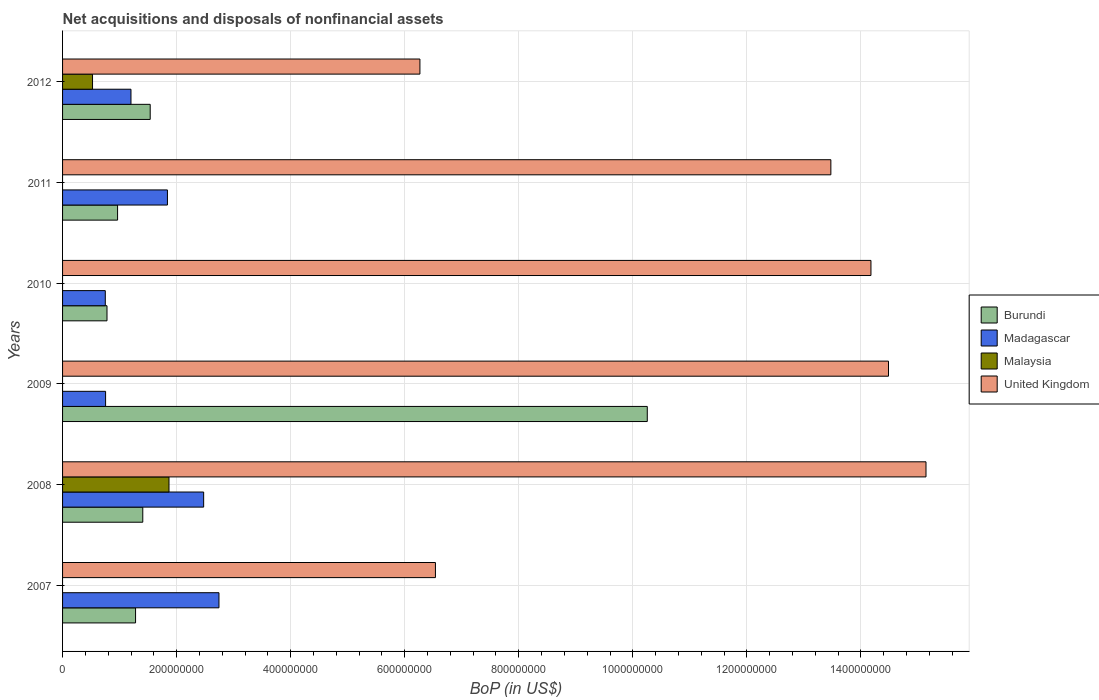How many different coloured bars are there?
Your answer should be very brief. 4. Are the number of bars on each tick of the Y-axis equal?
Give a very brief answer. No. How many bars are there on the 2nd tick from the top?
Offer a very short reply. 3. What is the Balance of Payments in Burundi in 2008?
Your answer should be very brief. 1.41e+08. Across all years, what is the maximum Balance of Payments in United Kingdom?
Offer a very short reply. 1.51e+09. Across all years, what is the minimum Balance of Payments in Burundi?
Make the answer very short. 7.79e+07. What is the total Balance of Payments in Burundi in the graph?
Your answer should be compact. 1.62e+09. What is the difference between the Balance of Payments in United Kingdom in 2007 and that in 2010?
Your response must be concise. -7.64e+08. What is the difference between the Balance of Payments in United Kingdom in 2009 and the Balance of Payments in Madagascar in 2008?
Provide a short and direct response. 1.20e+09. What is the average Balance of Payments in Madagascar per year?
Give a very brief answer. 1.63e+08. In the year 2008, what is the difference between the Balance of Payments in Malaysia and Balance of Payments in United Kingdom?
Keep it short and to the point. -1.33e+09. In how many years, is the Balance of Payments in Malaysia greater than 80000000 US$?
Give a very brief answer. 1. What is the ratio of the Balance of Payments in United Kingdom in 2010 to that in 2011?
Provide a short and direct response. 1.05. What is the difference between the highest and the second highest Balance of Payments in Madagascar?
Provide a short and direct response. 2.68e+07. What is the difference between the highest and the lowest Balance of Payments in Burundi?
Give a very brief answer. 9.47e+08. Is the sum of the Balance of Payments in United Kingdom in 2008 and 2011 greater than the maximum Balance of Payments in Madagascar across all years?
Offer a terse response. Yes. How many bars are there?
Give a very brief answer. 20. How many years are there in the graph?
Give a very brief answer. 6. What is the difference between two consecutive major ticks on the X-axis?
Provide a short and direct response. 2.00e+08. Are the values on the major ticks of X-axis written in scientific E-notation?
Provide a succinct answer. No. Does the graph contain any zero values?
Ensure brevity in your answer.  Yes. Where does the legend appear in the graph?
Your answer should be compact. Center right. How are the legend labels stacked?
Your response must be concise. Vertical. What is the title of the graph?
Your answer should be very brief. Net acquisitions and disposals of nonfinancial assets. Does "Cayman Islands" appear as one of the legend labels in the graph?
Make the answer very short. No. What is the label or title of the X-axis?
Your response must be concise. BoP (in US$). What is the BoP (in US$) in Burundi in 2007?
Your answer should be very brief. 1.28e+08. What is the BoP (in US$) of Madagascar in 2007?
Your response must be concise. 2.74e+08. What is the BoP (in US$) of Malaysia in 2007?
Ensure brevity in your answer.  0. What is the BoP (in US$) of United Kingdom in 2007?
Your answer should be very brief. 6.54e+08. What is the BoP (in US$) in Burundi in 2008?
Ensure brevity in your answer.  1.41e+08. What is the BoP (in US$) of Madagascar in 2008?
Give a very brief answer. 2.47e+08. What is the BoP (in US$) in Malaysia in 2008?
Your response must be concise. 1.87e+08. What is the BoP (in US$) of United Kingdom in 2008?
Your answer should be very brief. 1.51e+09. What is the BoP (in US$) of Burundi in 2009?
Provide a succinct answer. 1.03e+09. What is the BoP (in US$) in Madagascar in 2009?
Keep it short and to the point. 7.55e+07. What is the BoP (in US$) in Malaysia in 2009?
Provide a succinct answer. 0. What is the BoP (in US$) in United Kingdom in 2009?
Give a very brief answer. 1.45e+09. What is the BoP (in US$) of Burundi in 2010?
Ensure brevity in your answer.  7.79e+07. What is the BoP (in US$) of Madagascar in 2010?
Your answer should be compact. 7.49e+07. What is the BoP (in US$) of Malaysia in 2010?
Offer a terse response. 0. What is the BoP (in US$) in United Kingdom in 2010?
Provide a succinct answer. 1.42e+09. What is the BoP (in US$) of Burundi in 2011?
Your response must be concise. 9.65e+07. What is the BoP (in US$) of Madagascar in 2011?
Your response must be concise. 1.84e+08. What is the BoP (in US$) in Malaysia in 2011?
Ensure brevity in your answer.  0. What is the BoP (in US$) in United Kingdom in 2011?
Your response must be concise. 1.35e+09. What is the BoP (in US$) in Burundi in 2012?
Give a very brief answer. 1.54e+08. What is the BoP (in US$) of Madagascar in 2012?
Ensure brevity in your answer.  1.20e+08. What is the BoP (in US$) in Malaysia in 2012?
Give a very brief answer. 5.25e+07. What is the BoP (in US$) of United Kingdom in 2012?
Your response must be concise. 6.27e+08. Across all years, what is the maximum BoP (in US$) of Burundi?
Provide a succinct answer. 1.03e+09. Across all years, what is the maximum BoP (in US$) in Madagascar?
Offer a terse response. 2.74e+08. Across all years, what is the maximum BoP (in US$) of Malaysia?
Your answer should be compact. 1.87e+08. Across all years, what is the maximum BoP (in US$) in United Kingdom?
Your answer should be very brief. 1.51e+09. Across all years, what is the minimum BoP (in US$) in Burundi?
Your answer should be compact. 7.79e+07. Across all years, what is the minimum BoP (in US$) of Madagascar?
Offer a terse response. 7.49e+07. Across all years, what is the minimum BoP (in US$) in United Kingdom?
Make the answer very short. 6.27e+08. What is the total BoP (in US$) of Burundi in the graph?
Keep it short and to the point. 1.62e+09. What is the total BoP (in US$) in Madagascar in the graph?
Your answer should be compact. 9.76e+08. What is the total BoP (in US$) of Malaysia in the graph?
Offer a terse response. 2.39e+08. What is the total BoP (in US$) of United Kingdom in the graph?
Give a very brief answer. 7.01e+09. What is the difference between the BoP (in US$) of Burundi in 2007 and that in 2008?
Give a very brief answer. -1.27e+07. What is the difference between the BoP (in US$) in Madagascar in 2007 and that in 2008?
Your response must be concise. 2.68e+07. What is the difference between the BoP (in US$) of United Kingdom in 2007 and that in 2008?
Your response must be concise. -8.60e+08. What is the difference between the BoP (in US$) of Burundi in 2007 and that in 2009?
Provide a short and direct response. -8.97e+08. What is the difference between the BoP (in US$) of Madagascar in 2007 and that in 2009?
Ensure brevity in your answer.  1.99e+08. What is the difference between the BoP (in US$) of United Kingdom in 2007 and that in 2009?
Your answer should be compact. -7.94e+08. What is the difference between the BoP (in US$) of Burundi in 2007 and that in 2010?
Ensure brevity in your answer.  5.01e+07. What is the difference between the BoP (in US$) of Madagascar in 2007 and that in 2010?
Provide a short and direct response. 1.99e+08. What is the difference between the BoP (in US$) of United Kingdom in 2007 and that in 2010?
Provide a short and direct response. -7.64e+08. What is the difference between the BoP (in US$) in Burundi in 2007 and that in 2011?
Make the answer very short. 3.15e+07. What is the difference between the BoP (in US$) of Madagascar in 2007 and that in 2011?
Your response must be concise. 9.04e+07. What is the difference between the BoP (in US$) of United Kingdom in 2007 and that in 2011?
Give a very brief answer. -6.93e+08. What is the difference between the BoP (in US$) in Burundi in 2007 and that in 2012?
Ensure brevity in your answer.  -2.57e+07. What is the difference between the BoP (in US$) in Madagascar in 2007 and that in 2012?
Your answer should be compact. 1.54e+08. What is the difference between the BoP (in US$) of United Kingdom in 2007 and that in 2012?
Your response must be concise. 2.72e+07. What is the difference between the BoP (in US$) of Burundi in 2008 and that in 2009?
Your answer should be very brief. -8.85e+08. What is the difference between the BoP (in US$) in Madagascar in 2008 and that in 2009?
Make the answer very short. 1.72e+08. What is the difference between the BoP (in US$) of United Kingdom in 2008 and that in 2009?
Your answer should be compact. 6.58e+07. What is the difference between the BoP (in US$) of Burundi in 2008 and that in 2010?
Your response must be concise. 6.28e+07. What is the difference between the BoP (in US$) in Madagascar in 2008 and that in 2010?
Offer a very short reply. 1.72e+08. What is the difference between the BoP (in US$) in United Kingdom in 2008 and that in 2010?
Give a very brief answer. 9.65e+07. What is the difference between the BoP (in US$) of Burundi in 2008 and that in 2011?
Offer a very short reply. 4.42e+07. What is the difference between the BoP (in US$) of Madagascar in 2008 and that in 2011?
Provide a succinct answer. 6.35e+07. What is the difference between the BoP (in US$) of United Kingdom in 2008 and that in 2011?
Provide a succinct answer. 1.67e+08. What is the difference between the BoP (in US$) in Burundi in 2008 and that in 2012?
Give a very brief answer. -1.30e+07. What is the difference between the BoP (in US$) of Madagascar in 2008 and that in 2012?
Provide a short and direct response. 1.27e+08. What is the difference between the BoP (in US$) in Malaysia in 2008 and that in 2012?
Offer a very short reply. 1.34e+08. What is the difference between the BoP (in US$) in United Kingdom in 2008 and that in 2012?
Your answer should be very brief. 8.87e+08. What is the difference between the BoP (in US$) of Burundi in 2009 and that in 2010?
Your answer should be compact. 9.47e+08. What is the difference between the BoP (in US$) of Madagascar in 2009 and that in 2010?
Offer a terse response. 5.31e+05. What is the difference between the BoP (in US$) of United Kingdom in 2009 and that in 2010?
Your answer should be very brief. 3.08e+07. What is the difference between the BoP (in US$) in Burundi in 2009 and that in 2011?
Make the answer very short. 9.29e+08. What is the difference between the BoP (in US$) of Madagascar in 2009 and that in 2011?
Offer a terse response. -1.08e+08. What is the difference between the BoP (in US$) of United Kingdom in 2009 and that in 2011?
Your response must be concise. 1.01e+08. What is the difference between the BoP (in US$) in Burundi in 2009 and that in 2012?
Give a very brief answer. 8.72e+08. What is the difference between the BoP (in US$) in Madagascar in 2009 and that in 2012?
Provide a succinct answer. -4.45e+07. What is the difference between the BoP (in US$) of United Kingdom in 2009 and that in 2012?
Keep it short and to the point. 8.22e+08. What is the difference between the BoP (in US$) of Burundi in 2010 and that in 2011?
Your answer should be very brief. -1.86e+07. What is the difference between the BoP (in US$) in Madagascar in 2010 and that in 2011?
Offer a terse response. -1.09e+08. What is the difference between the BoP (in US$) of United Kingdom in 2010 and that in 2011?
Your response must be concise. 7.03e+07. What is the difference between the BoP (in US$) in Burundi in 2010 and that in 2012?
Give a very brief answer. -7.58e+07. What is the difference between the BoP (in US$) of Madagascar in 2010 and that in 2012?
Provide a short and direct response. -4.50e+07. What is the difference between the BoP (in US$) in United Kingdom in 2010 and that in 2012?
Your response must be concise. 7.91e+08. What is the difference between the BoP (in US$) of Burundi in 2011 and that in 2012?
Provide a short and direct response. -5.72e+07. What is the difference between the BoP (in US$) of Madagascar in 2011 and that in 2012?
Offer a very short reply. 6.40e+07. What is the difference between the BoP (in US$) in United Kingdom in 2011 and that in 2012?
Offer a very short reply. 7.21e+08. What is the difference between the BoP (in US$) in Burundi in 2007 and the BoP (in US$) in Madagascar in 2008?
Give a very brief answer. -1.19e+08. What is the difference between the BoP (in US$) of Burundi in 2007 and the BoP (in US$) of Malaysia in 2008?
Provide a short and direct response. -5.86e+07. What is the difference between the BoP (in US$) of Burundi in 2007 and the BoP (in US$) of United Kingdom in 2008?
Your answer should be compact. -1.39e+09. What is the difference between the BoP (in US$) in Madagascar in 2007 and the BoP (in US$) in Malaysia in 2008?
Your response must be concise. 8.76e+07. What is the difference between the BoP (in US$) in Madagascar in 2007 and the BoP (in US$) in United Kingdom in 2008?
Offer a terse response. -1.24e+09. What is the difference between the BoP (in US$) of Burundi in 2007 and the BoP (in US$) of Madagascar in 2009?
Make the answer very short. 5.26e+07. What is the difference between the BoP (in US$) of Burundi in 2007 and the BoP (in US$) of United Kingdom in 2009?
Your response must be concise. -1.32e+09. What is the difference between the BoP (in US$) in Madagascar in 2007 and the BoP (in US$) in United Kingdom in 2009?
Offer a terse response. -1.17e+09. What is the difference between the BoP (in US$) in Burundi in 2007 and the BoP (in US$) in Madagascar in 2010?
Provide a succinct answer. 5.31e+07. What is the difference between the BoP (in US$) of Burundi in 2007 and the BoP (in US$) of United Kingdom in 2010?
Provide a short and direct response. -1.29e+09. What is the difference between the BoP (in US$) of Madagascar in 2007 and the BoP (in US$) of United Kingdom in 2010?
Keep it short and to the point. -1.14e+09. What is the difference between the BoP (in US$) in Burundi in 2007 and the BoP (in US$) in Madagascar in 2011?
Ensure brevity in your answer.  -5.59e+07. What is the difference between the BoP (in US$) in Burundi in 2007 and the BoP (in US$) in United Kingdom in 2011?
Your response must be concise. -1.22e+09. What is the difference between the BoP (in US$) of Madagascar in 2007 and the BoP (in US$) of United Kingdom in 2011?
Keep it short and to the point. -1.07e+09. What is the difference between the BoP (in US$) in Burundi in 2007 and the BoP (in US$) in Madagascar in 2012?
Keep it short and to the point. 8.08e+06. What is the difference between the BoP (in US$) of Burundi in 2007 and the BoP (in US$) of Malaysia in 2012?
Your answer should be very brief. 7.55e+07. What is the difference between the BoP (in US$) of Burundi in 2007 and the BoP (in US$) of United Kingdom in 2012?
Your response must be concise. -4.99e+08. What is the difference between the BoP (in US$) of Madagascar in 2007 and the BoP (in US$) of Malaysia in 2012?
Your answer should be very brief. 2.22e+08. What is the difference between the BoP (in US$) in Madagascar in 2007 and the BoP (in US$) in United Kingdom in 2012?
Make the answer very short. -3.52e+08. What is the difference between the BoP (in US$) in Burundi in 2008 and the BoP (in US$) in Madagascar in 2009?
Offer a terse response. 6.52e+07. What is the difference between the BoP (in US$) of Burundi in 2008 and the BoP (in US$) of United Kingdom in 2009?
Keep it short and to the point. -1.31e+09. What is the difference between the BoP (in US$) in Madagascar in 2008 and the BoP (in US$) in United Kingdom in 2009?
Your response must be concise. -1.20e+09. What is the difference between the BoP (in US$) of Malaysia in 2008 and the BoP (in US$) of United Kingdom in 2009?
Provide a succinct answer. -1.26e+09. What is the difference between the BoP (in US$) of Burundi in 2008 and the BoP (in US$) of Madagascar in 2010?
Keep it short and to the point. 6.57e+07. What is the difference between the BoP (in US$) of Burundi in 2008 and the BoP (in US$) of United Kingdom in 2010?
Offer a very short reply. -1.28e+09. What is the difference between the BoP (in US$) of Madagascar in 2008 and the BoP (in US$) of United Kingdom in 2010?
Provide a succinct answer. -1.17e+09. What is the difference between the BoP (in US$) of Malaysia in 2008 and the BoP (in US$) of United Kingdom in 2010?
Give a very brief answer. -1.23e+09. What is the difference between the BoP (in US$) in Burundi in 2008 and the BoP (in US$) in Madagascar in 2011?
Provide a succinct answer. -4.32e+07. What is the difference between the BoP (in US$) in Burundi in 2008 and the BoP (in US$) in United Kingdom in 2011?
Offer a terse response. -1.21e+09. What is the difference between the BoP (in US$) in Madagascar in 2008 and the BoP (in US$) in United Kingdom in 2011?
Make the answer very short. -1.10e+09. What is the difference between the BoP (in US$) of Malaysia in 2008 and the BoP (in US$) of United Kingdom in 2011?
Keep it short and to the point. -1.16e+09. What is the difference between the BoP (in US$) in Burundi in 2008 and the BoP (in US$) in Madagascar in 2012?
Your response must be concise. 2.07e+07. What is the difference between the BoP (in US$) in Burundi in 2008 and the BoP (in US$) in Malaysia in 2012?
Offer a very short reply. 8.81e+07. What is the difference between the BoP (in US$) in Burundi in 2008 and the BoP (in US$) in United Kingdom in 2012?
Offer a very short reply. -4.86e+08. What is the difference between the BoP (in US$) in Madagascar in 2008 and the BoP (in US$) in Malaysia in 2012?
Your answer should be very brief. 1.95e+08. What is the difference between the BoP (in US$) in Madagascar in 2008 and the BoP (in US$) in United Kingdom in 2012?
Offer a terse response. -3.79e+08. What is the difference between the BoP (in US$) in Malaysia in 2008 and the BoP (in US$) in United Kingdom in 2012?
Your response must be concise. -4.40e+08. What is the difference between the BoP (in US$) of Burundi in 2009 and the BoP (in US$) of Madagascar in 2010?
Keep it short and to the point. 9.50e+08. What is the difference between the BoP (in US$) in Burundi in 2009 and the BoP (in US$) in United Kingdom in 2010?
Your answer should be very brief. -3.92e+08. What is the difference between the BoP (in US$) of Madagascar in 2009 and the BoP (in US$) of United Kingdom in 2010?
Offer a very short reply. -1.34e+09. What is the difference between the BoP (in US$) in Burundi in 2009 and the BoP (in US$) in Madagascar in 2011?
Offer a very short reply. 8.41e+08. What is the difference between the BoP (in US$) of Burundi in 2009 and the BoP (in US$) of United Kingdom in 2011?
Offer a terse response. -3.22e+08. What is the difference between the BoP (in US$) of Madagascar in 2009 and the BoP (in US$) of United Kingdom in 2011?
Make the answer very short. -1.27e+09. What is the difference between the BoP (in US$) of Burundi in 2009 and the BoP (in US$) of Madagascar in 2012?
Keep it short and to the point. 9.05e+08. What is the difference between the BoP (in US$) in Burundi in 2009 and the BoP (in US$) in Malaysia in 2012?
Ensure brevity in your answer.  9.73e+08. What is the difference between the BoP (in US$) of Burundi in 2009 and the BoP (in US$) of United Kingdom in 2012?
Your answer should be compact. 3.99e+08. What is the difference between the BoP (in US$) in Madagascar in 2009 and the BoP (in US$) in Malaysia in 2012?
Offer a terse response. 2.29e+07. What is the difference between the BoP (in US$) of Madagascar in 2009 and the BoP (in US$) of United Kingdom in 2012?
Provide a short and direct response. -5.51e+08. What is the difference between the BoP (in US$) in Burundi in 2010 and the BoP (in US$) in Madagascar in 2011?
Your answer should be compact. -1.06e+08. What is the difference between the BoP (in US$) in Burundi in 2010 and the BoP (in US$) in United Kingdom in 2011?
Your answer should be very brief. -1.27e+09. What is the difference between the BoP (in US$) of Madagascar in 2010 and the BoP (in US$) of United Kingdom in 2011?
Give a very brief answer. -1.27e+09. What is the difference between the BoP (in US$) in Burundi in 2010 and the BoP (in US$) in Madagascar in 2012?
Your answer should be very brief. -4.20e+07. What is the difference between the BoP (in US$) of Burundi in 2010 and the BoP (in US$) of Malaysia in 2012?
Provide a short and direct response. 2.54e+07. What is the difference between the BoP (in US$) of Burundi in 2010 and the BoP (in US$) of United Kingdom in 2012?
Offer a very short reply. -5.49e+08. What is the difference between the BoP (in US$) of Madagascar in 2010 and the BoP (in US$) of Malaysia in 2012?
Your answer should be compact. 2.24e+07. What is the difference between the BoP (in US$) of Madagascar in 2010 and the BoP (in US$) of United Kingdom in 2012?
Offer a very short reply. -5.52e+08. What is the difference between the BoP (in US$) of Burundi in 2011 and the BoP (in US$) of Madagascar in 2012?
Your answer should be very brief. -2.35e+07. What is the difference between the BoP (in US$) of Burundi in 2011 and the BoP (in US$) of Malaysia in 2012?
Your answer should be very brief. 4.39e+07. What is the difference between the BoP (in US$) in Burundi in 2011 and the BoP (in US$) in United Kingdom in 2012?
Provide a short and direct response. -5.30e+08. What is the difference between the BoP (in US$) in Madagascar in 2011 and the BoP (in US$) in Malaysia in 2012?
Make the answer very short. 1.31e+08. What is the difference between the BoP (in US$) of Madagascar in 2011 and the BoP (in US$) of United Kingdom in 2012?
Offer a terse response. -4.43e+08. What is the average BoP (in US$) in Burundi per year?
Ensure brevity in your answer.  2.70e+08. What is the average BoP (in US$) in Madagascar per year?
Give a very brief answer. 1.63e+08. What is the average BoP (in US$) in Malaysia per year?
Keep it short and to the point. 3.99e+07. What is the average BoP (in US$) in United Kingdom per year?
Your response must be concise. 1.17e+09. In the year 2007, what is the difference between the BoP (in US$) of Burundi and BoP (in US$) of Madagascar?
Provide a short and direct response. -1.46e+08. In the year 2007, what is the difference between the BoP (in US$) in Burundi and BoP (in US$) in United Kingdom?
Your response must be concise. -5.26e+08. In the year 2007, what is the difference between the BoP (in US$) in Madagascar and BoP (in US$) in United Kingdom?
Give a very brief answer. -3.80e+08. In the year 2008, what is the difference between the BoP (in US$) in Burundi and BoP (in US$) in Madagascar?
Keep it short and to the point. -1.07e+08. In the year 2008, what is the difference between the BoP (in US$) of Burundi and BoP (in US$) of Malaysia?
Ensure brevity in your answer.  -4.60e+07. In the year 2008, what is the difference between the BoP (in US$) in Burundi and BoP (in US$) in United Kingdom?
Ensure brevity in your answer.  -1.37e+09. In the year 2008, what is the difference between the BoP (in US$) of Madagascar and BoP (in US$) of Malaysia?
Offer a very short reply. 6.08e+07. In the year 2008, what is the difference between the BoP (in US$) of Madagascar and BoP (in US$) of United Kingdom?
Your answer should be very brief. -1.27e+09. In the year 2008, what is the difference between the BoP (in US$) in Malaysia and BoP (in US$) in United Kingdom?
Keep it short and to the point. -1.33e+09. In the year 2009, what is the difference between the BoP (in US$) of Burundi and BoP (in US$) of Madagascar?
Provide a succinct answer. 9.50e+08. In the year 2009, what is the difference between the BoP (in US$) of Burundi and BoP (in US$) of United Kingdom?
Provide a succinct answer. -4.23e+08. In the year 2009, what is the difference between the BoP (in US$) in Madagascar and BoP (in US$) in United Kingdom?
Provide a short and direct response. -1.37e+09. In the year 2010, what is the difference between the BoP (in US$) in Burundi and BoP (in US$) in Madagascar?
Provide a short and direct response. 2.98e+06. In the year 2010, what is the difference between the BoP (in US$) in Burundi and BoP (in US$) in United Kingdom?
Offer a terse response. -1.34e+09. In the year 2010, what is the difference between the BoP (in US$) of Madagascar and BoP (in US$) of United Kingdom?
Make the answer very short. -1.34e+09. In the year 2011, what is the difference between the BoP (in US$) of Burundi and BoP (in US$) of Madagascar?
Your answer should be compact. -8.74e+07. In the year 2011, what is the difference between the BoP (in US$) in Burundi and BoP (in US$) in United Kingdom?
Provide a succinct answer. -1.25e+09. In the year 2011, what is the difference between the BoP (in US$) in Madagascar and BoP (in US$) in United Kingdom?
Your answer should be compact. -1.16e+09. In the year 2012, what is the difference between the BoP (in US$) in Burundi and BoP (in US$) in Madagascar?
Give a very brief answer. 3.37e+07. In the year 2012, what is the difference between the BoP (in US$) in Burundi and BoP (in US$) in Malaysia?
Ensure brevity in your answer.  1.01e+08. In the year 2012, what is the difference between the BoP (in US$) of Burundi and BoP (in US$) of United Kingdom?
Your response must be concise. -4.73e+08. In the year 2012, what is the difference between the BoP (in US$) of Madagascar and BoP (in US$) of Malaysia?
Your answer should be very brief. 6.74e+07. In the year 2012, what is the difference between the BoP (in US$) in Madagascar and BoP (in US$) in United Kingdom?
Offer a terse response. -5.07e+08. In the year 2012, what is the difference between the BoP (in US$) in Malaysia and BoP (in US$) in United Kingdom?
Keep it short and to the point. -5.74e+08. What is the ratio of the BoP (in US$) of Burundi in 2007 to that in 2008?
Ensure brevity in your answer.  0.91. What is the ratio of the BoP (in US$) in Madagascar in 2007 to that in 2008?
Provide a short and direct response. 1.11. What is the ratio of the BoP (in US$) of United Kingdom in 2007 to that in 2008?
Keep it short and to the point. 0.43. What is the ratio of the BoP (in US$) in Burundi in 2007 to that in 2009?
Offer a very short reply. 0.12. What is the ratio of the BoP (in US$) in Madagascar in 2007 to that in 2009?
Your answer should be compact. 3.63. What is the ratio of the BoP (in US$) in United Kingdom in 2007 to that in 2009?
Keep it short and to the point. 0.45. What is the ratio of the BoP (in US$) of Burundi in 2007 to that in 2010?
Offer a terse response. 1.64. What is the ratio of the BoP (in US$) in Madagascar in 2007 to that in 2010?
Offer a terse response. 3.66. What is the ratio of the BoP (in US$) in United Kingdom in 2007 to that in 2010?
Your answer should be compact. 0.46. What is the ratio of the BoP (in US$) of Burundi in 2007 to that in 2011?
Make the answer very short. 1.33. What is the ratio of the BoP (in US$) of Madagascar in 2007 to that in 2011?
Your answer should be very brief. 1.49. What is the ratio of the BoP (in US$) of United Kingdom in 2007 to that in 2011?
Your answer should be very brief. 0.49. What is the ratio of the BoP (in US$) in Burundi in 2007 to that in 2012?
Make the answer very short. 0.83. What is the ratio of the BoP (in US$) in Madagascar in 2007 to that in 2012?
Your response must be concise. 2.29. What is the ratio of the BoP (in US$) in United Kingdom in 2007 to that in 2012?
Give a very brief answer. 1.04. What is the ratio of the BoP (in US$) in Burundi in 2008 to that in 2009?
Make the answer very short. 0.14. What is the ratio of the BoP (in US$) in Madagascar in 2008 to that in 2009?
Keep it short and to the point. 3.28. What is the ratio of the BoP (in US$) in United Kingdom in 2008 to that in 2009?
Ensure brevity in your answer.  1.05. What is the ratio of the BoP (in US$) in Burundi in 2008 to that in 2010?
Provide a succinct answer. 1.81. What is the ratio of the BoP (in US$) in Madagascar in 2008 to that in 2010?
Offer a very short reply. 3.3. What is the ratio of the BoP (in US$) of United Kingdom in 2008 to that in 2010?
Your answer should be very brief. 1.07. What is the ratio of the BoP (in US$) in Burundi in 2008 to that in 2011?
Your answer should be compact. 1.46. What is the ratio of the BoP (in US$) in Madagascar in 2008 to that in 2011?
Your answer should be compact. 1.35. What is the ratio of the BoP (in US$) in United Kingdom in 2008 to that in 2011?
Ensure brevity in your answer.  1.12. What is the ratio of the BoP (in US$) of Burundi in 2008 to that in 2012?
Your response must be concise. 0.92. What is the ratio of the BoP (in US$) in Madagascar in 2008 to that in 2012?
Ensure brevity in your answer.  2.06. What is the ratio of the BoP (in US$) in Malaysia in 2008 to that in 2012?
Make the answer very short. 3.55. What is the ratio of the BoP (in US$) in United Kingdom in 2008 to that in 2012?
Ensure brevity in your answer.  2.42. What is the ratio of the BoP (in US$) in Burundi in 2009 to that in 2010?
Offer a very short reply. 13.16. What is the ratio of the BoP (in US$) of Madagascar in 2009 to that in 2010?
Your response must be concise. 1.01. What is the ratio of the BoP (in US$) of United Kingdom in 2009 to that in 2010?
Ensure brevity in your answer.  1.02. What is the ratio of the BoP (in US$) in Burundi in 2009 to that in 2011?
Your answer should be compact. 10.63. What is the ratio of the BoP (in US$) of Madagascar in 2009 to that in 2011?
Your answer should be compact. 0.41. What is the ratio of the BoP (in US$) in United Kingdom in 2009 to that in 2011?
Your answer should be very brief. 1.07. What is the ratio of the BoP (in US$) in Burundi in 2009 to that in 2012?
Offer a terse response. 6.67. What is the ratio of the BoP (in US$) in Madagascar in 2009 to that in 2012?
Your answer should be compact. 0.63. What is the ratio of the BoP (in US$) in United Kingdom in 2009 to that in 2012?
Keep it short and to the point. 2.31. What is the ratio of the BoP (in US$) in Burundi in 2010 to that in 2011?
Make the answer very short. 0.81. What is the ratio of the BoP (in US$) of Madagascar in 2010 to that in 2011?
Keep it short and to the point. 0.41. What is the ratio of the BoP (in US$) in United Kingdom in 2010 to that in 2011?
Your answer should be compact. 1.05. What is the ratio of the BoP (in US$) of Burundi in 2010 to that in 2012?
Ensure brevity in your answer.  0.51. What is the ratio of the BoP (in US$) of Madagascar in 2010 to that in 2012?
Offer a terse response. 0.62. What is the ratio of the BoP (in US$) in United Kingdom in 2010 to that in 2012?
Make the answer very short. 2.26. What is the ratio of the BoP (in US$) of Burundi in 2011 to that in 2012?
Offer a very short reply. 0.63. What is the ratio of the BoP (in US$) in Madagascar in 2011 to that in 2012?
Your answer should be compact. 1.53. What is the ratio of the BoP (in US$) in United Kingdom in 2011 to that in 2012?
Make the answer very short. 2.15. What is the difference between the highest and the second highest BoP (in US$) of Burundi?
Ensure brevity in your answer.  8.72e+08. What is the difference between the highest and the second highest BoP (in US$) in Madagascar?
Make the answer very short. 2.68e+07. What is the difference between the highest and the second highest BoP (in US$) in United Kingdom?
Make the answer very short. 6.58e+07. What is the difference between the highest and the lowest BoP (in US$) of Burundi?
Provide a succinct answer. 9.47e+08. What is the difference between the highest and the lowest BoP (in US$) in Madagascar?
Ensure brevity in your answer.  1.99e+08. What is the difference between the highest and the lowest BoP (in US$) in Malaysia?
Provide a short and direct response. 1.87e+08. What is the difference between the highest and the lowest BoP (in US$) of United Kingdom?
Provide a succinct answer. 8.87e+08. 